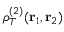<formula> <loc_0><loc_0><loc_500><loc_500>\rho _ { T } ^ { ( 2 ) } ( { r } _ { 1 } , { r } _ { 2 } )</formula> 